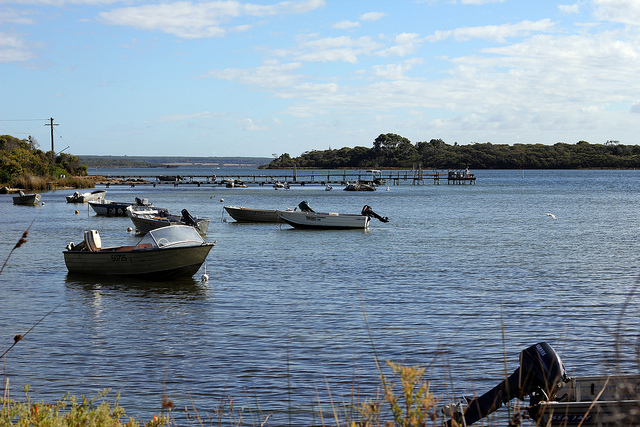If this scene could be a painting, what style would it be? If this scene could be translated into a painting, it would likely be best rendered in the Impressionist style. With gentle brush strokes capturing the play of light on the water and sky, and a focus on the overall tranquility and essence rather than precise detail, it would beautifully convey the peacefulness and harmony of nature. The use of soft, blended colors would further enhance the feeling of serenity and timelessness. 